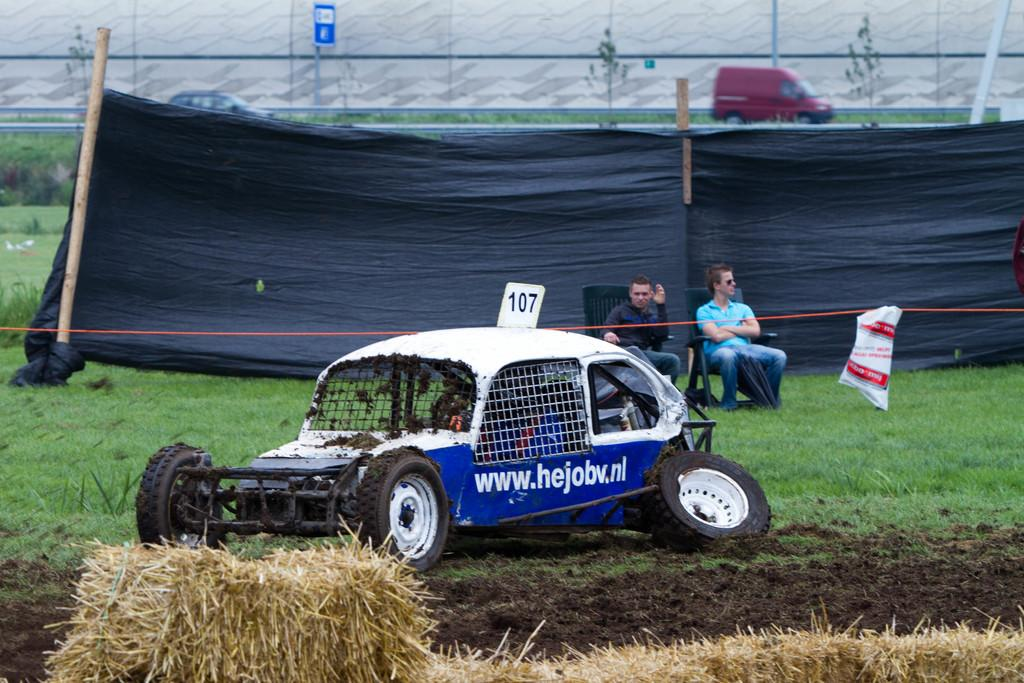How many people are sitting in chairs in the image? There are two people sitting in chairs in the image. What is at the bottom of the image? There is hay at the bottom of the image. What type of shelter is present in the image? There is a tent in the image. What material is used to create the flooring in the image? There are boards in the image. What can be seen on the road in the image? Vehicles are visible on the road in the image. What type of clam is being used as a doorstop for the tent in the image? There are no clams present in the image, and therefore no clams are being used as a doorstop for the tent. 